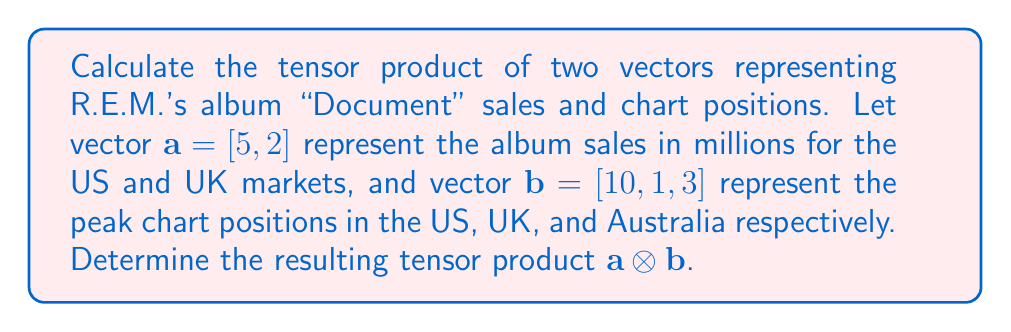Could you help me with this problem? To calculate the tensor product of two vectors, we multiply each element of the first vector by every element of the second vector. The result is a matrix with dimensions equal to the product of the dimensions of the input vectors.

Given:
$\mathbf{a} = [5, 2]$ (2x1 vector)
$\mathbf{b} = [10, 1, 3]$ (3x1 vector)

The resulting tensor product will be a 2x3 matrix.

Step 1: Multiply the first element of $\mathbf{a}$ by each element of $\mathbf{b}$:
$5 \cdot [10, 1, 3] = [50, 5, 15]$

Step 2: Multiply the second element of $\mathbf{a}$ by each element of $\mathbf{b}$:
$2 \cdot [10, 1, 3] = [20, 2, 6]$

Step 3: Arrange the results in a 2x3 matrix:

$$\mathbf{a} \otimes \mathbf{b} = \begin{bmatrix}
50 & 5 & 15 \\
20 & 2 & 6
\end{bmatrix}$$

This matrix represents the tensor product of album sales and chart positions, providing a comprehensive view of the album's performance across different markets.
Answer: $$\begin{bmatrix}
50 & 5 & 15 \\
20 & 2 & 6
\end{bmatrix}$$ 